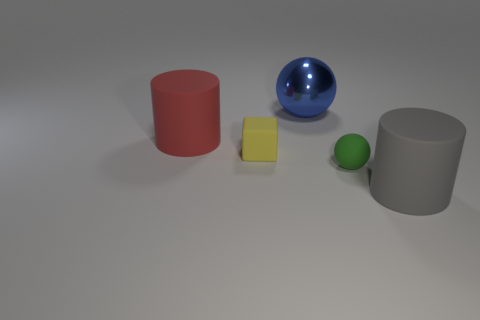There is a red cylinder that is the same material as the cube; what size is it? The red cylinder appears to be medium-sized in comparison to the other objects in the image, specifically it seems to be larger than the small green sphere but smaller than the blue sphere and the grey cylinder. Its exact dimensions cannot be determined from the image alone without a reference scale. 